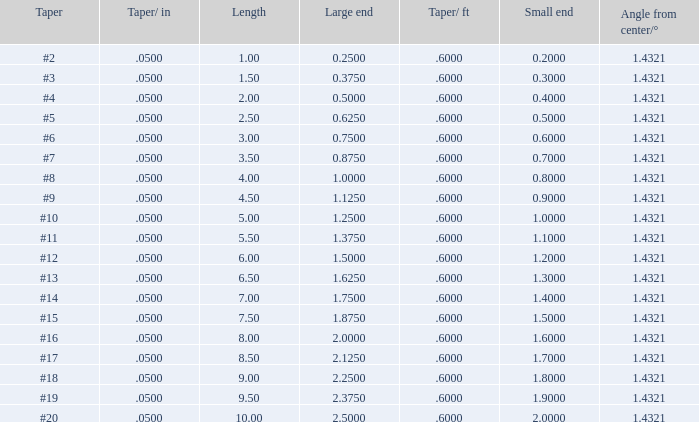Which Large end has a Taper/ft smaller than 0.6000000000000001? 19.0. 